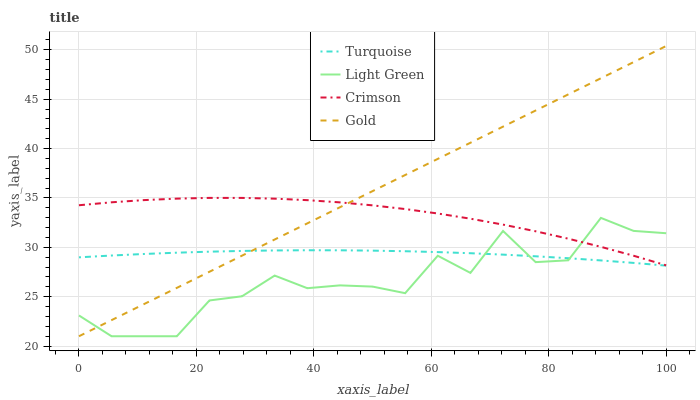Does Light Green have the minimum area under the curve?
Answer yes or no. Yes. Does Gold have the maximum area under the curve?
Answer yes or no. Yes. Does Turquoise have the minimum area under the curve?
Answer yes or no. No. Does Turquoise have the maximum area under the curve?
Answer yes or no. No. Is Gold the smoothest?
Answer yes or no. Yes. Is Light Green the roughest?
Answer yes or no. Yes. Is Turquoise the smoothest?
Answer yes or no. No. Is Turquoise the roughest?
Answer yes or no. No. Does Gold have the lowest value?
Answer yes or no. Yes. Does Turquoise have the lowest value?
Answer yes or no. No. Does Gold have the highest value?
Answer yes or no. Yes. Does Turquoise have the highest value?
Answer yes or no. No. Is Turquoise less than Crimson?
Answer yes or no. Yes. Is Crimson greater than Turquoise?
Answer yes or no. Yes. Does Gold intersect Light Green?
Answer yes or no. Yes. Is Gold less than Light Green?
Answer yes or no. No. Is Gold greater than Light Green?
Answer yes or no. No. Does Turquoise intersect Crimson?
Answer yes or no. No. 